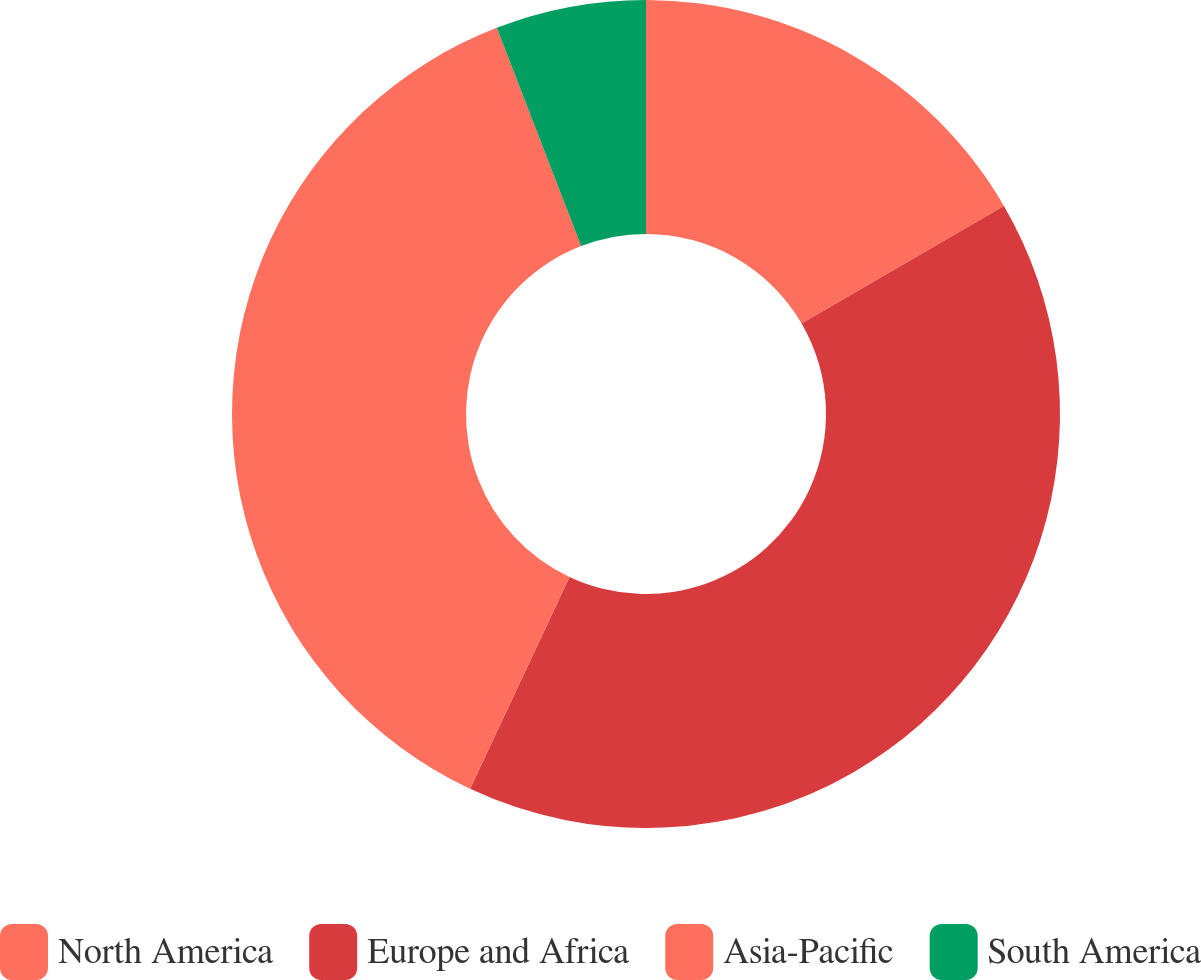<chart> <loc_0><loc_0><loc_500><loc_500><pie_chart><fcel>North America<fcel>Europe and Africa<fcel>Asia-Pacific<fcel>South America<nl><fcel>16.62%<fcel>40.37%<fcel>37.15%<fcel>5.87%<nl></chart> 